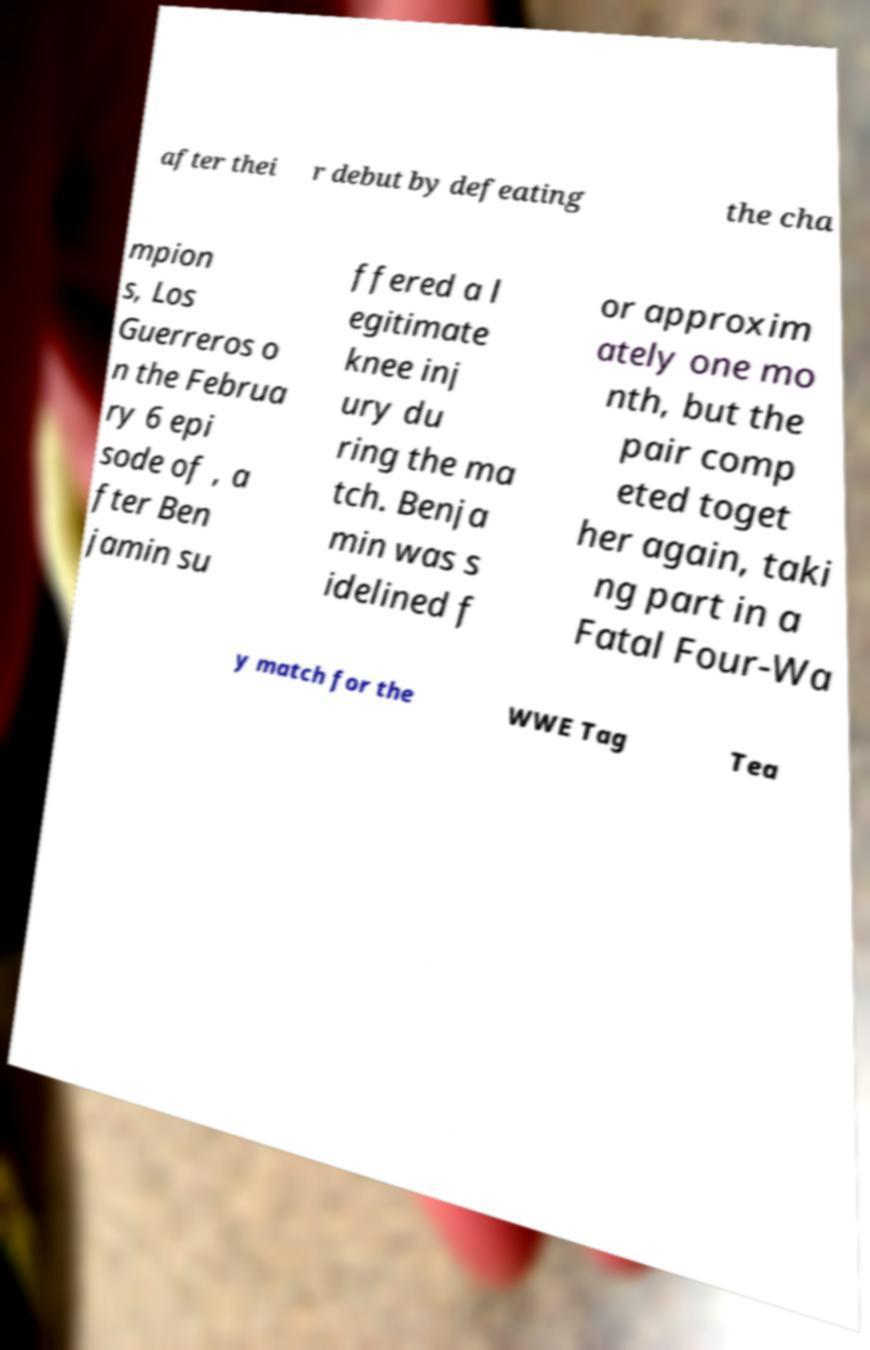I need the written content from this picture converted into text. Can you do that? after thei r debut by defeating the cha mpion s, Los Guerreros o n the Februa ry 6 epi sode of , a fter Ben jamin su ffered a l egitimate knee inj ury du ring the ma tch. Benja min was s idelined f or approxim ately one mo nth, but the pair comp eted toget her again, taki ng part in a Fatal Four-Wa y match for the WWE Tag Tea 